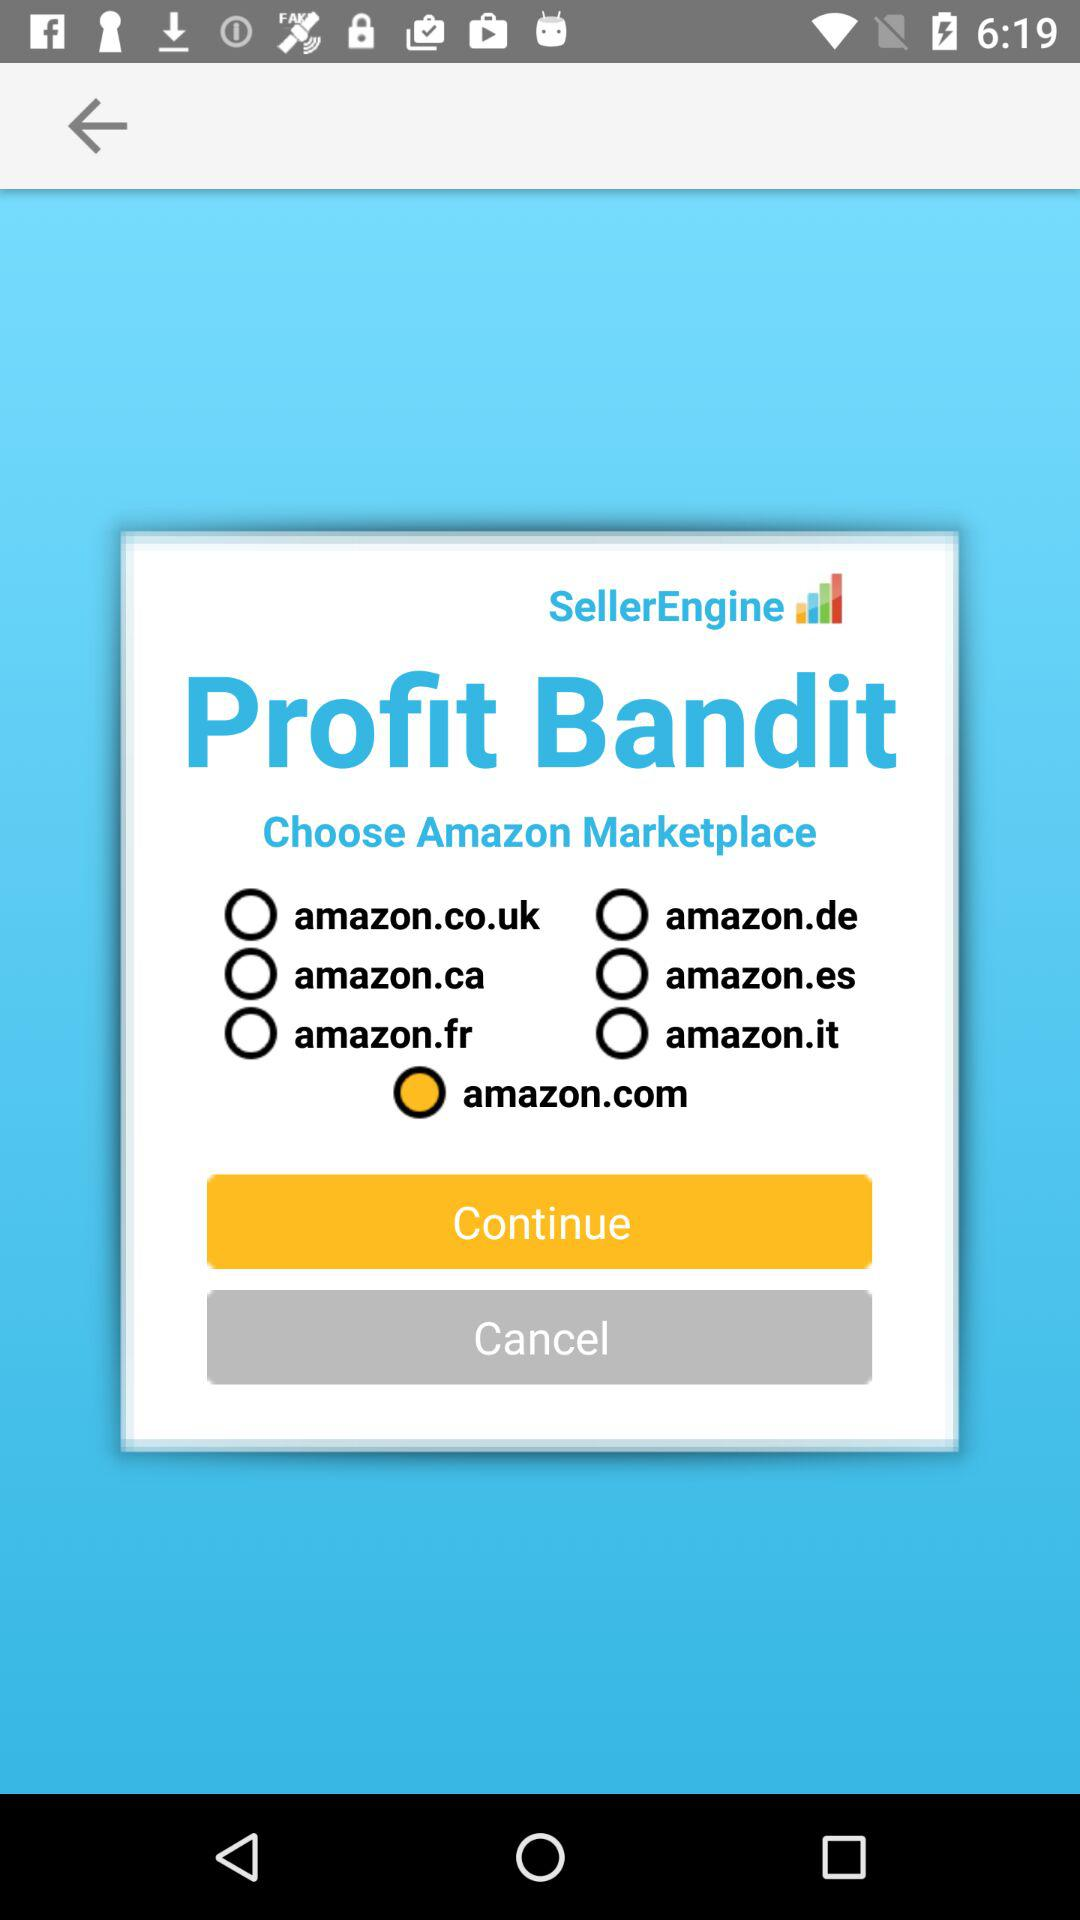Which version of "Profit Bandit" is this?
When the provided information is insufficient, respond with <no answer>. <no answer> 